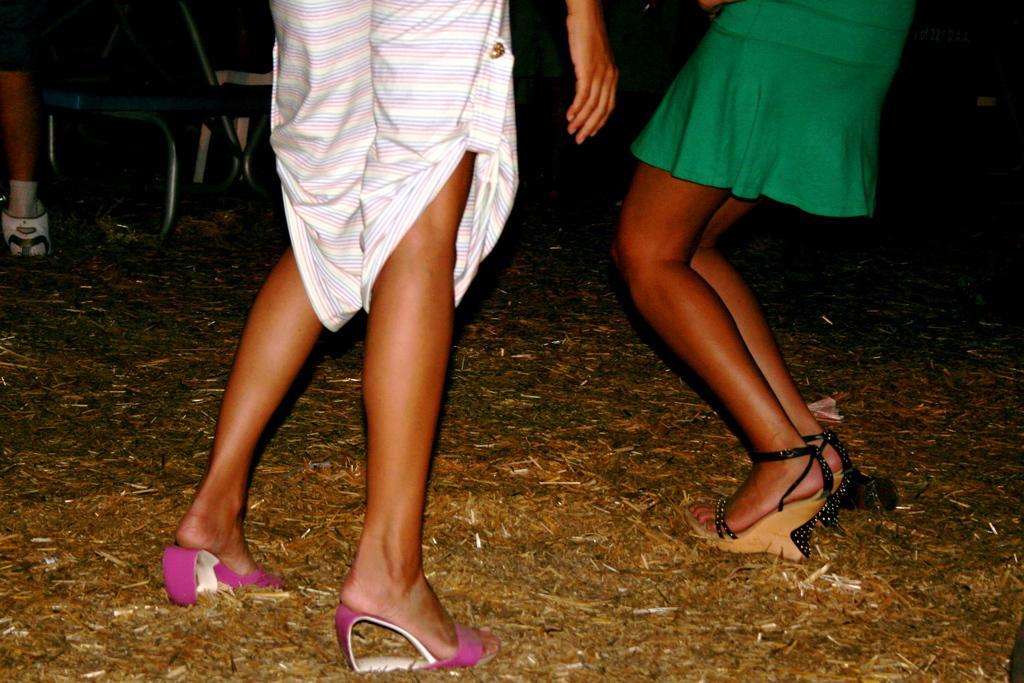Could you give a brief overview of what you see in this image? In this image we can see two persons legs standing on the ground. The background of the image is dark, where we can see some objects. 